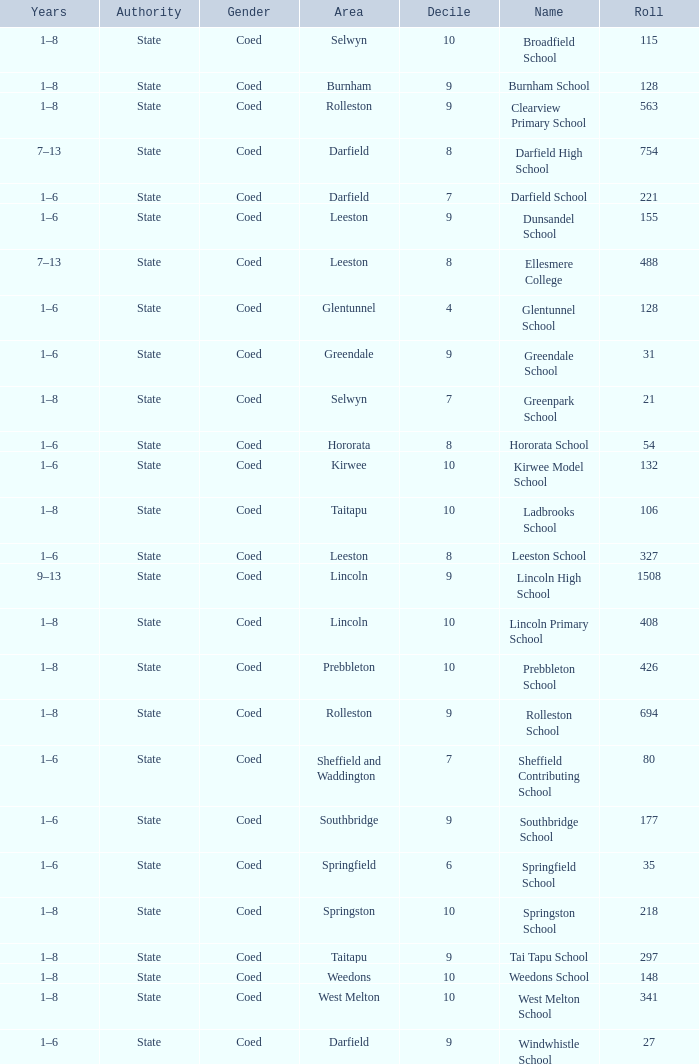What is the name with a Decile less than 10, and a Roll of 297? Tai Tapu School. 